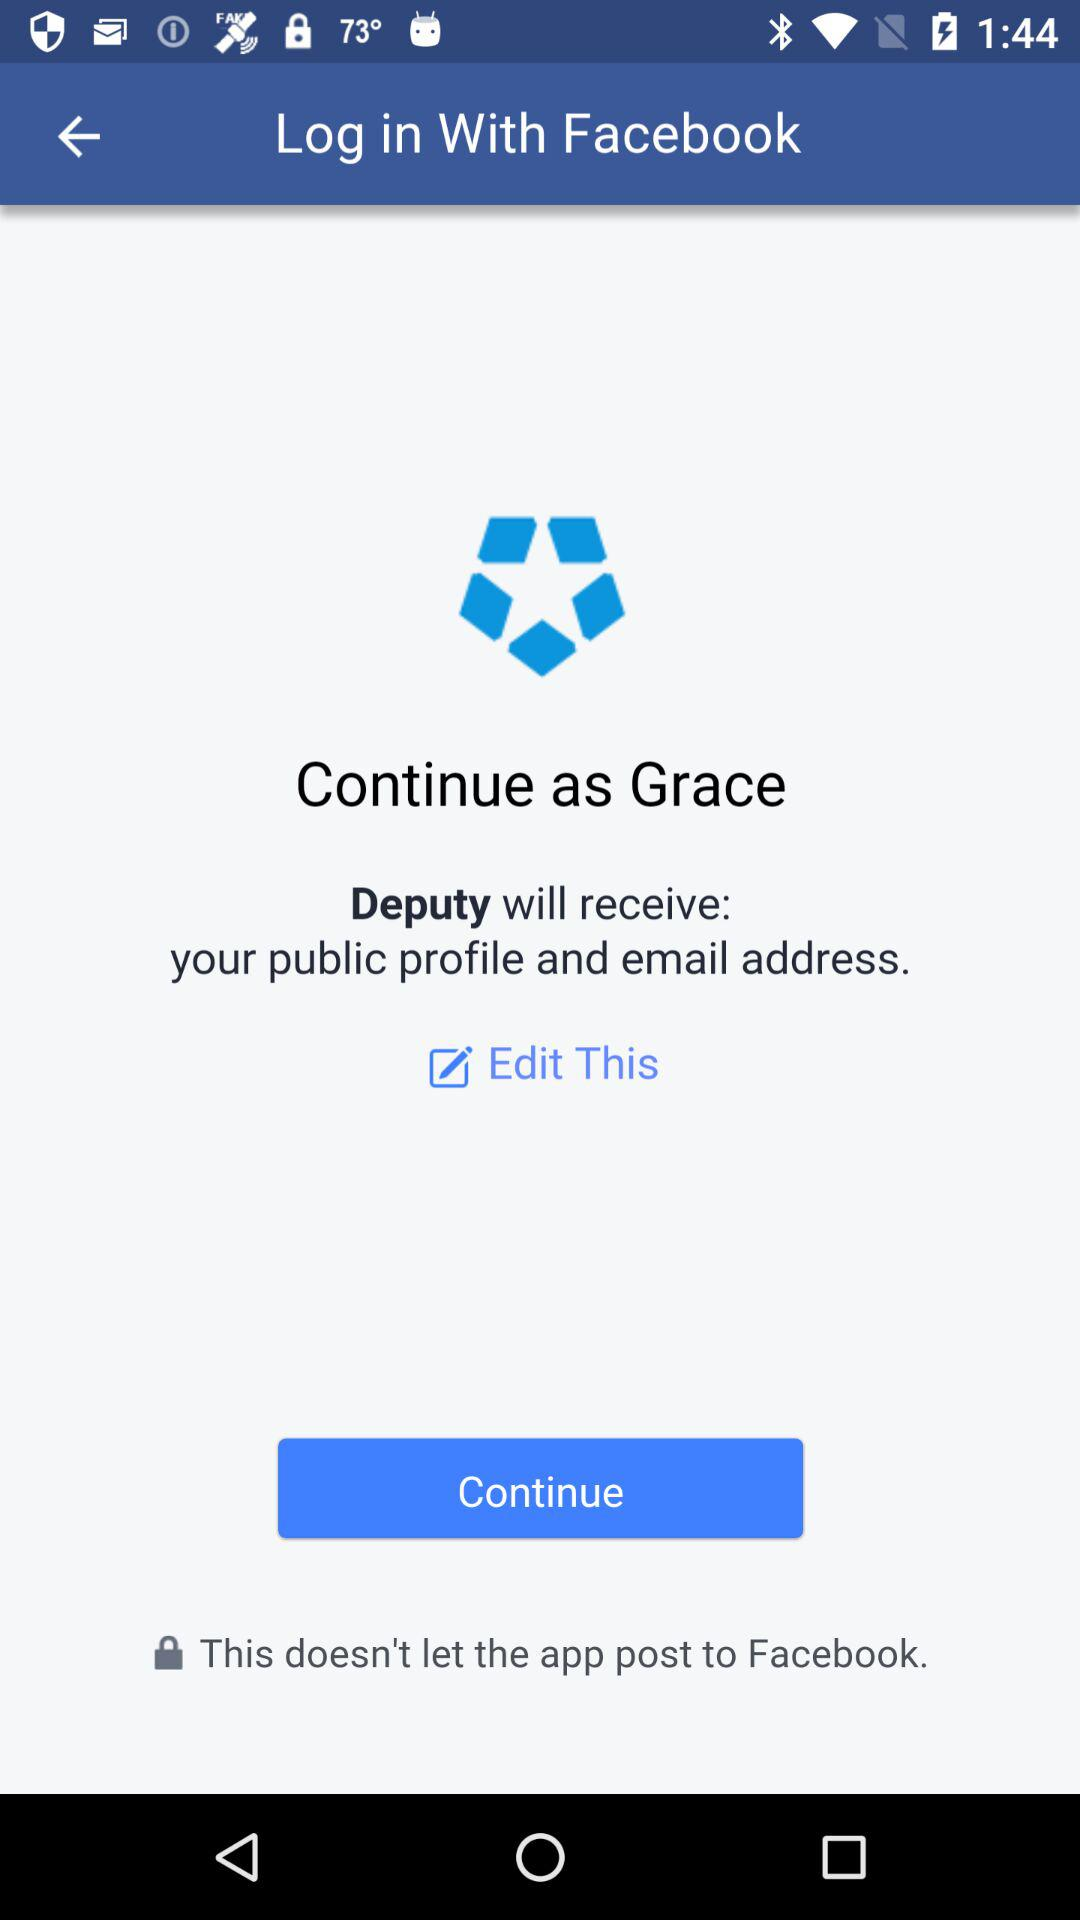What application is asking for permission? The application "Deputy" is asking for permission. 